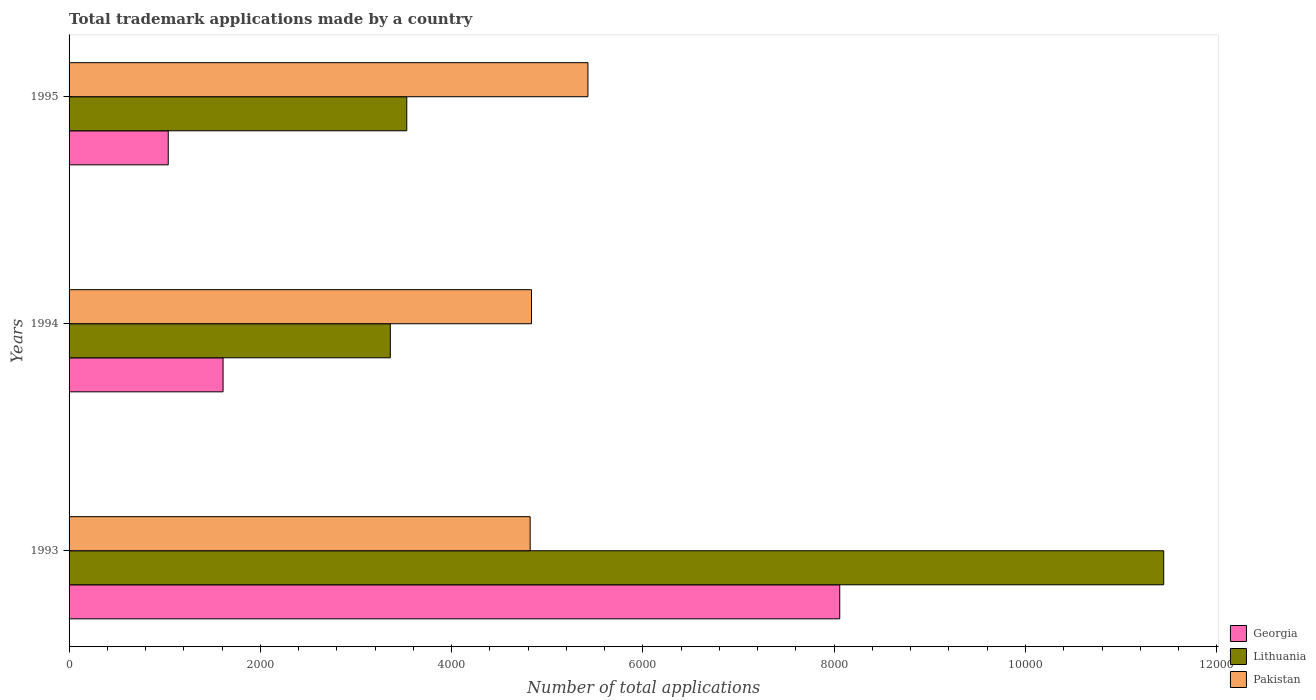How many different coloured bars are there?
Your answer should be compact. 3. How many groups of bars are there?
Keep it short and to the point. 3. How many bars are there on the 2nd tick from the top?
Offer a very short reply. 3. How many bars are there on the 2nd tick from the bottom?
Your response must be concise. 3. What is the label of the 3rd group of bars from the top?
Ensure brevity in your answer.  1993. In how many cases, is the number of bars for a given year not equal to the number of legend labels?
Your response must be concise. 0. What is the number of applications made by in Lithuania in 1994?
Your answer should be compact. 3359. Across all years, what is the maximum number of applications made by in Pakistan?
Keep it short and to the point. 5425. Across all years, what is the minimum number of applications made by in Pakistan?
Provide a short and direct response. 4821. In which year was the number of applications made by in Lithuania maximum?
Give a very brief answer. 1993. In which year was the number of applications made by in Lithuania minimum?
Your response must be concise. 1994. What is the total number of applications made by in Lithuania in the graph?
Keep it short and to the point. 1.83e+04. What is the difference between the number of applications made by in Pakistan in 1994 and that in 1995?
Provide a short and direct response. -590. What is the difference between the number of applications made by in Lithuania in 1993 and the number of applications made by in Georgia in 1994?
Ensure brevity in your answer.  9835. What is the average number of applications made by in Pakistan per year?
Ensure brevity in your answer.  5027. In the year 1995, what is the difference between the number of applications made by in Georgia and number of applications made by in Lithuania?
Make the answer very short. -2494. In how many years, is the number of applications made by in Georgia greater than 1200 ?
Your answer should be compact. 2. What is the ratio of the number of applications made by in Georgia in 1993 to that in 1995?
Keep it short and to the point. 7.77. What is the difference between the highest and the second highest number of applications made by in Georgia?
Keep it short and to the point. 6448. What is the difference between the highest and the lowest number of applications made by in Pakistan?
Your response must be concise. 604. In how many years, is the number of applications made by in Georgia greater than the average number of applications made by in Georgia taken over all years?
Ensure brevity in your answer.  1. Is the sum of the number of applications made by in Georgia in 1994 and 1995 greater than the maximum number of applications made by in Lithuania across all years?
Offer a terse response. No. What does the 3rd bar from the top in 1995 represents?
Give a very brief answer. Georgia. What does the 1st bar from the bottom in 1994 represents?
Provide a succinct answer. Georgia. How many bars are there?
Offer a very short reply. 9. Are all the bars in the graph horizontal?
Your answer should be very brief. Yes. Are the values on the major ticks of X-axis written in scientific E-notation?
Offer a very short reply. No. Where does the legend appear in the graph?
Provide a short and direct response. Bottom right. How many legend labels are there?
Ensure brevity in your answer.  3. What is the title of the graph?
Give a very brief answer. Total trademark applications made by a country. Does "Greenland" appear as one of the legend labels in the graph?
Ensure brevity in your answer.  No. What is the label or title of the X-axis?
Your answer should be very brief. Number of total applications. What is the label or title of the Y-axis?
Offer a very short reply. Years. What is the Number of total applications in Georgia in 1993?
Your answer should be very brief. 8058. What is the Number of total applications of Lithuania in 1993?
Make the answer very short. 1.14e+04. What is the Number of total applications of Pakistan in 1993?
Offer a very short reply. 4821. What is the Number of total applications in Georgia in 1994?
Your answer should be very brief. 1610. What is the Number of total applications of Lithuania in 1994?
Your answer should be very brief. 3359. What is the Number of total applications in Pakistan in 1994?
Offer a very short reply. 4835. What is the Number of total applications in Georgia in 1995?
Provide a succinct answer. 1037. What is the Number of total applications in Lithuania in 1995?
Make the answer very short. 3531. What is the Number of total applications of Pakistan in 1995?
Provide a succinct answer. 5425. Across all years, what is the maximum Number of total applications of Georgia?
Give a very brief answer. 8058. Across all years, what is the maximum Number of total applications in Lithuania?
Give a very brief answer. 1.14e+04. Across all years, what is the maximum Number of total applications in Pakistan?
Give a very brief answer. 5425. Across all years, what is the minimum Number of total applications in Georgia?
Keep it short and to the point. 1037. Across all years, what is the minimum Number of total applications of Lithuania?
Your answer should be very brief. 3359. Across all years, what is the minimum Number of total applications in Pakistan?
Your answer should be compact. 4821. What is the total Number of total applications of Georgia in the graph?
Give a very brief answer. 1.07e+04. What is the total Number of total applications in Lithuania in the graph?
Offer a very short reply. 1.83e+04. What is the total Number of total applications in Pakistan in the graph?
Keep it short and to the point. 1.51e+04. What is the difference between the Number of total applications in Georgia in 1993 and that in 1994?
Offer a very short reply. 6448. What is the difference between the Number of total applications in Lithuania in 1993 and that in 1994?
Provide a short and direct response. 8086. What is the difference between the Number of total applications of Georgia in 1993 and that in 1995?
Keep it short and to the point. 7021. What is the difference between the Number of total applications of Lithuania in 1993 and that in 1995?
Offer a terse response. 7914. What is the difference between the Number of total applications in Pakistan in 1993 and that in 1995?
Your response must be concise. -604. What is the difference between the Number of total applications in Georgia in 1994 and that in 1995?
Ensure brevity in your answer.  573. What is the difference between the Number of total applications in Lithuania in 1994 and that in 1995?
Give a very brief answer. -172. What is the difference between the Number of total applications in Pakistan in 1994 and that in 1995?
Your answer should be very brief. -590. What is the difference between the Number of total applications of Georgia in 1993 and the Number of total applications of Lithuania in 1994?
Make the answer very short. 4699. What is the difference between the Number of total applications in Georgia in 1993 and the Number of total applications in Pakistan in 1994?
Make the answer very short. 3223. What is the difference between the Number of total applications in Lithuania in 1993 and the Number of total applications in Pakistan in 1994?
Your answer should be compact. 6610. What is the difference between the Number of total applications of Georgia in 1993 and the Number of total applications of Lithuania in 1995?
Offer a terse response. 4527. What is the difference between the Number of total applications of Georgia in 1993 and the Number of total applications of Pakistan in 1995?
Provide a short and direct response. 2633. What is the difference between the Number of total applications of Lithuania in 1993 and the Number of total applications of Pakistan in 1995?
Ensure brevity in your answer.  6020. What is the difference between the Number of total applications of Georgia in 1994 and the Number of total applications of Lithuania in 1995?
Your answer should be very brief. -1921. What is the difference between the Number of total applications in Georgia in 1994 and the Number of total applications in Pakistan in 1995?
Ensure brevity in your answer.  -3815. What is the difference between the Number of total applications in Lithuania in 1994 and the Number of total applications in Pakistan in 1995?
Ensure brevity in your answer.  -2066. What is the average Number of total applications of Georgia per year?
Give a very brief answer. 3568.33. What is the average Number of total applications of Lithuania per year?
Make the answer very short. 6111.67. What is the average Number of total applications in Pakistan per year?
Give a very brief answer. 5027. In the year 1993, what is the difference between the Number of total applications of Georgia and Number of total applications of Lithuania?
Give a very brief answer. -3387. In the year 1993, what is the difference between the Number of total applications of Georgia and Number of total applications of Pakistan?
Offer a very short reply. 3237. In the year 1993, what is the difference between the Number of total applications in Lithuania and Number of total applications in Pakistan?
Provide a short and direct response. 6624. In the year 1994, what is the difference between the Number of total applications in Georgia and Number of total applications in Lithuania?
Offer a very short reply. -1749. In the year 1994, what is the difference between the Number of total applications of Georgia and Number of total applications of Pakistan?
Offer a terse response. -3225. In the year 1994, what is the difference between the Number of total applications of Lithuania and Number of total applications of Pakistan?
Make the answer very short. -1476. In the year 1995, what is the difference between the Number of total applications of Georgia and Number of total applications of Lithuania?
Your answer should be compact. -2494. In the year 1995, what is the difference between the Number of total applications in Georgia and Number of total applications in Pakistan?
Provide a succinct answer. -4388. In the year 1995, what is the difference between the Number of total applications in Lithuania and Number of total applications in Pakistan?
Provide a short and direct response. -1894. What is the ratio of the Number of total applications in Georgia in 1993 to that in 1994?
Your response must be concise. 5. What is the ratio of the Number of total applications of Lithuania in 1993 to that in 1994?
Your response must be concise. 3.41. What is the ratio of the Number of total applications of Georgia in 1993 to that in 1995?
Your response must be concise. 7.77. What is the ratio of the Number of total applications of Lithuania in 1993 to that in 1995?
Provide a succinct answer. 3.24. What is the ratio of the Number of total applications of Pakistan in 1993 to that in 1995?
Make the answer very short. 0.89. What is the ratio of the Number of total applications of Georgia in 1994 to that in 1995?
Give a very brief answer. 1.55. What is the ratio of the Number of total applications in Lithuania in 1994 to that in 1995?
Offer a terse response. 0.95. What is the ratio of the Number of total applications in Pakistan in 1994 to that in 1995?
Provide a succinct answer. 0.89. What is the difference between the highest and the second highest Number of total applications of Georgia?
Make the answer very short. 6448. What is the difference between the highest and the second highest Number of total applications of Lithuania?
Offer a terse response. 7914. What is the difference between the highest and the second highest Number of total applications of Pakistan?
Give a very brief answer. 590. What is the difference between the highest and the lowest Number of total applications of Georgia?
Provide a short and direct response. 7021. What is the difference between the highest and the lowest Number of total applications of Lithuania?
Your response must be concise. 8086. What is the difference between the highest and the lowest Number of total applications of Pakistan?
Offer a very short reply. 604. 